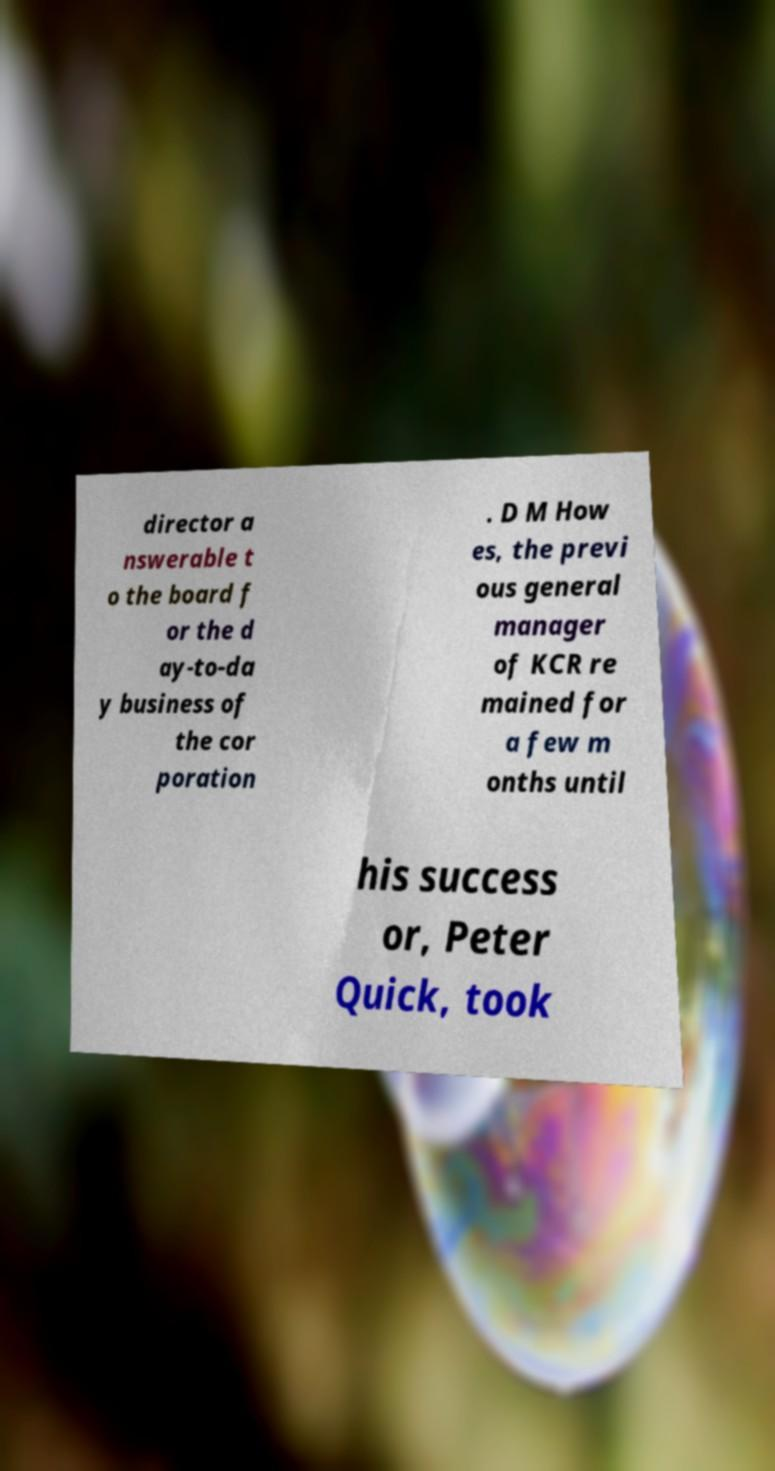Can you read and provide the text displayed in the image?This photo seems to have some interesting text. Can you extract and type it out for me? director a nswerable t o the board f or the d ay-to-da y business of the cor poration . D M How es, the previ ous general manager of KCR re mained for a few m onths until his success or, Peter Quick, took 